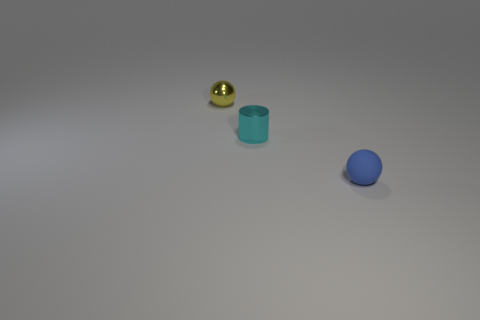Add 2 tiny cyan metallic objects. How many objects exist? 5 Subtract all cylinders. How many objects are left? 2 Subtract 0 cyan blocks. How many objects are left? 3 Subtract all cyan balls. Subtract all matte balls. How many objects are left? 2 Add 2 blue rubber balls. How many blue rubber balls are left? 3 Add 3 yellow shiny balls. How many yellow shiny balls exist? 4 